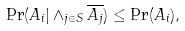Convert formula to latex. <formula><loc_0><loc_0><loc_500><loc_500>\Pr ( A _ { i } | \wedge _ { j \in S } \overline { A _ { j } } ) \leq \Pr ( A _ { i } ) ,</formula> 